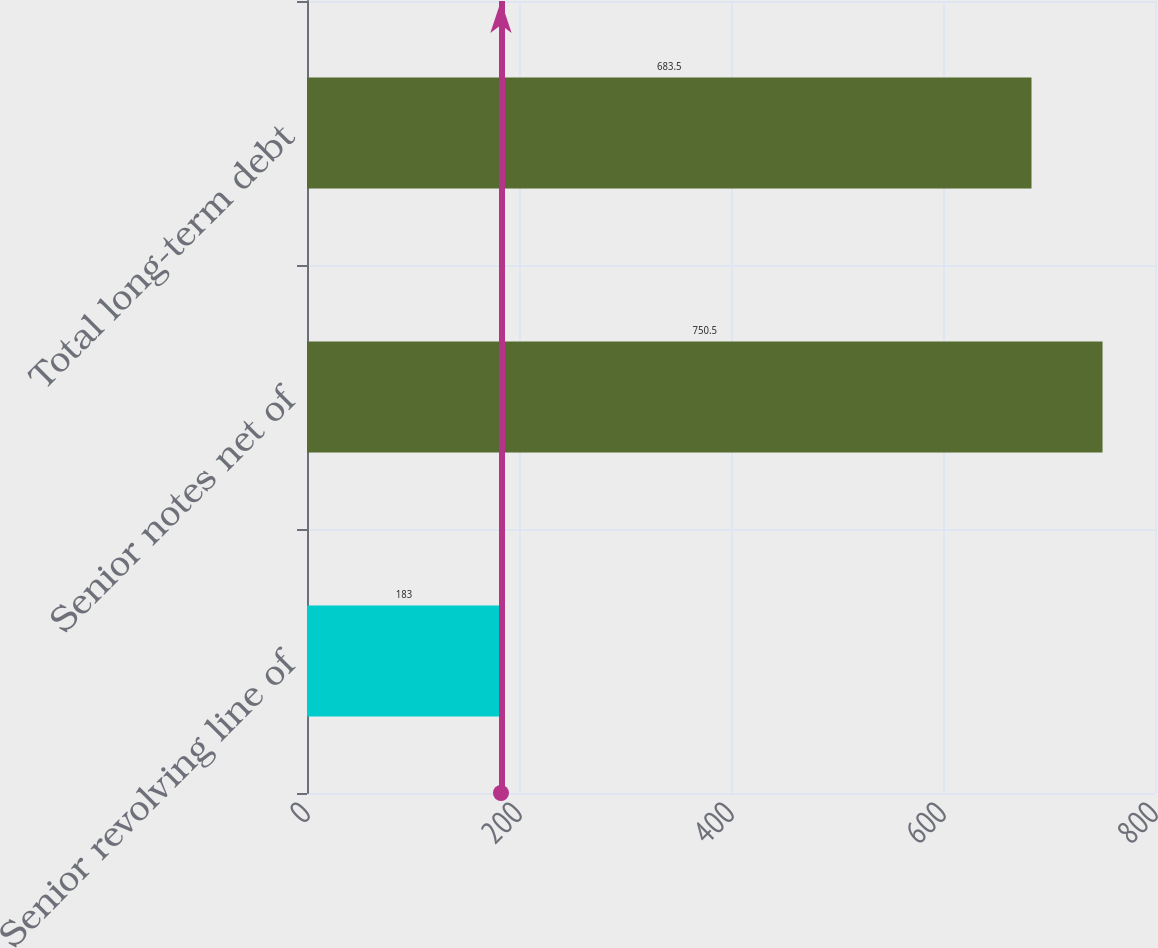<chart> <loc_0><loc_0><loc_500><loc_500><bar_chart><fcel>Senior revolving line of<fcel>Senior notes net of<fcel>Total long-term debt<nl><fcel>183<fcel>750.5<fcel>683.5<nl></chart> 